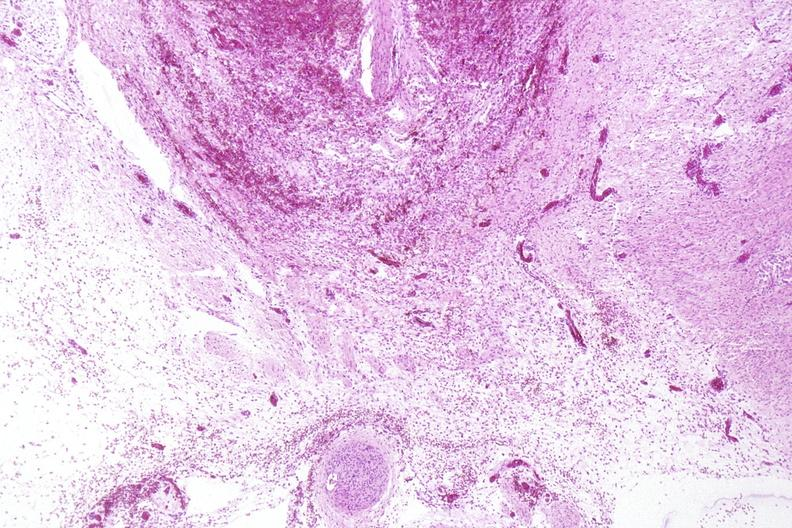s yellow color present?
Answer the question using a single word or phrase. No 